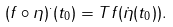Convert formula to latex. <formula><loc_0><loc_0><loc_500><loc_500>( f \circ \eta ) ^ { \cdot } ( t _ { 0 } ) = T f ( \dot { \eta } ( t _ { 0 } ) ) .</formula> 